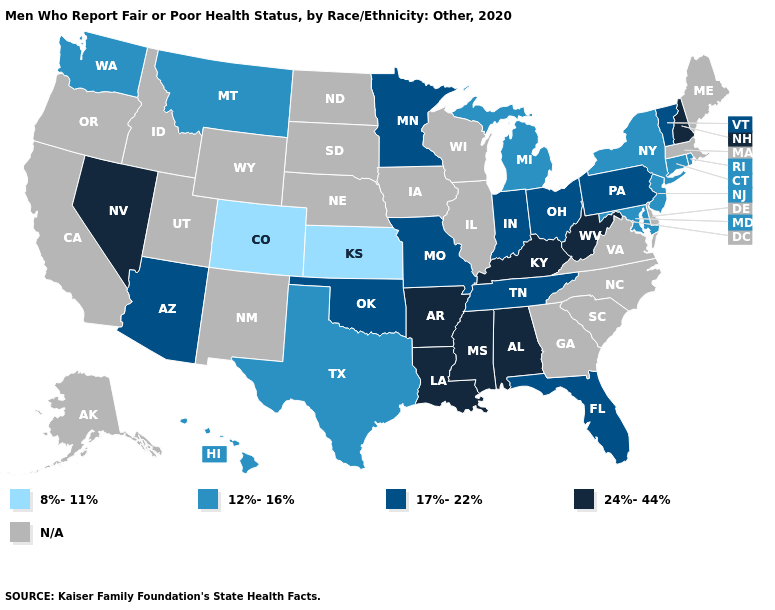What is the value of Utah?
Short answer required. N/A. Name the states that have a value in the range 8%-11%?
Keep it brief. Colorado, Kansas. Among the states that border Alabama , does Mississippi have the highest value?
Give a very brief answer. Yes. What is the value of Tennessee?
Answer briefly. 17%-22%. Does West Virginia have the lowest value in the South?
Give a very brief answer. No. Does the map have missing data?
Answer briefly. Yes. Name the states that have a value in the range 24%-44%?
Short answer required. Alabama, Arkansas, Kentucky, Louisiana, Mississippi, Nevada, New Hampshire, West Virginia. Among the states that border Arkansas , which have the lowest value?
Concise answer only. Texas. Among the states that border Arkansas , does Texas have the lowest value?
Concise answer only. Yes. Which states have the lowest value in the Northeast?
Answer briefly. Connecticut, New Jersey, New York, Rhode Island. What is the value of West Virginia?
Quick response, please. 24%-44%. Name the states that have a value in the range 17%-22%?
Be succinct. Arizona, Florida, Indiana, Minnesota, Missouri, Ohio, Oklahoma, Pennsylvania, Tennessee, Vermont. 